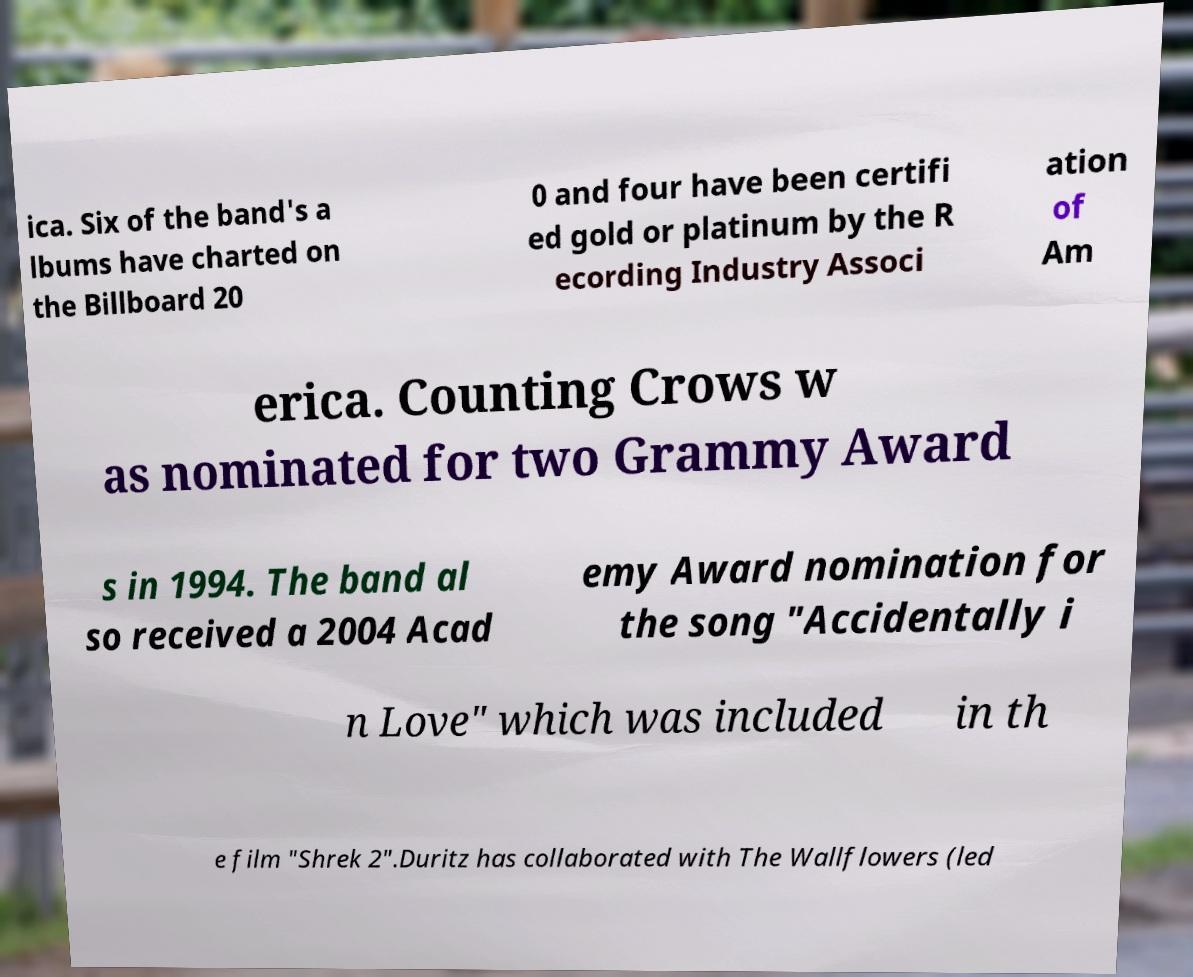Please identify and transcribe the text found in this image. ica. Six of the band's a lbums have charted on the Billboard 20 0 and four have been certifi ed gold or platinum by the R ecording Industry Associ ation of Am erica. Counting Crows w as nominated for two Grammy Award s in 1994. The band al so received a 2004 Acad emy Award nomination for the song "Accidentally i n Love" which was included in th e film "Shrek 2".Duritz has collaborated with The Wallflowers (led 